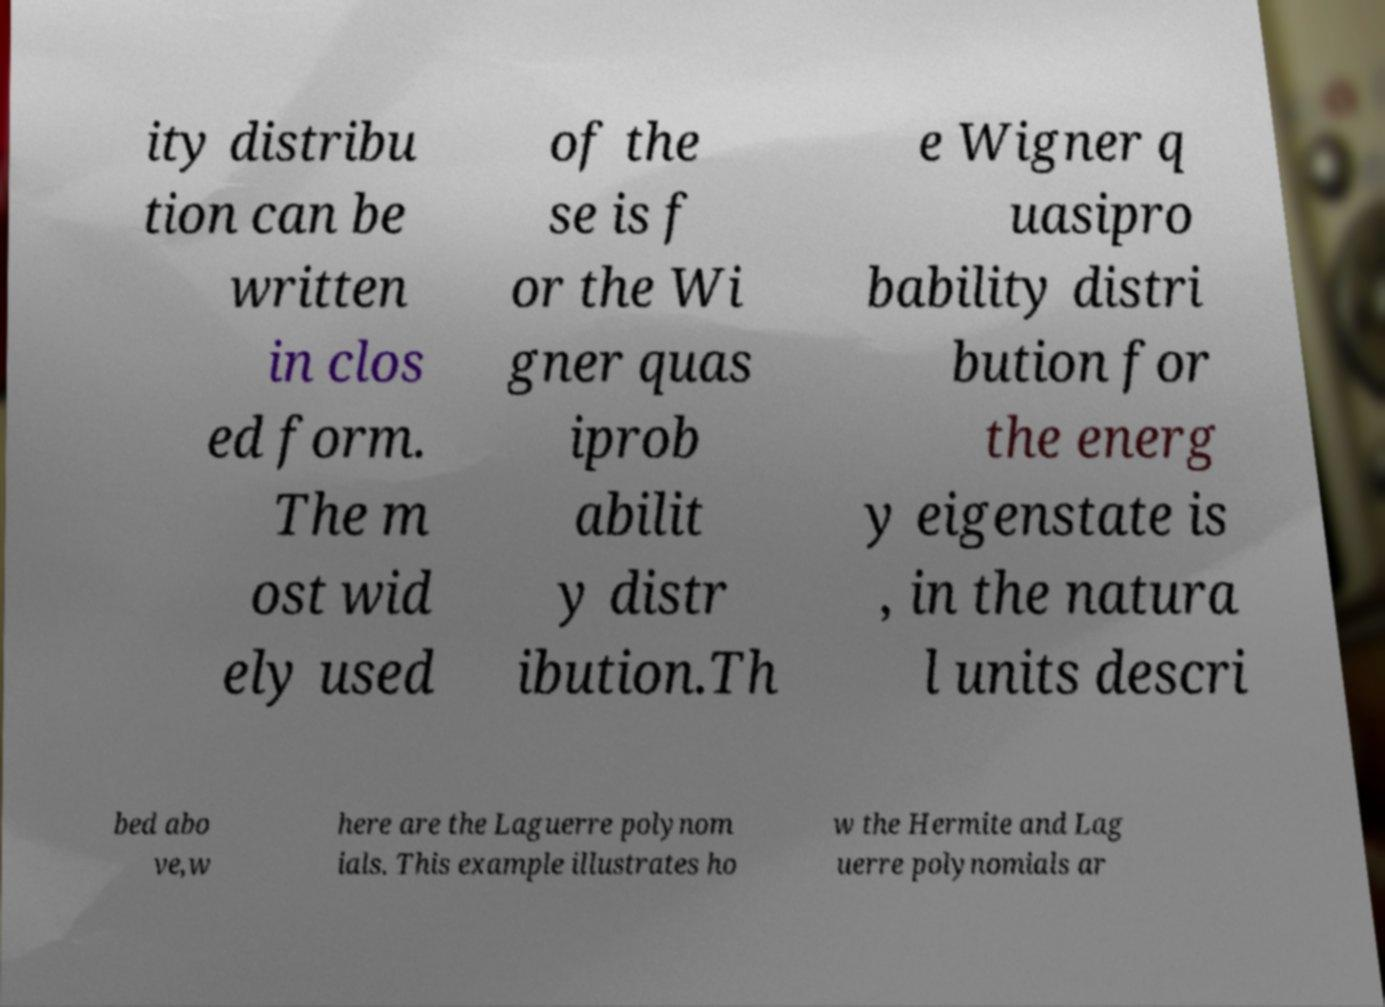I need the written content from this picture converted into text. Can you do that? ity distribu tion can be written in clos ed form. The m ost wid ely used of the se is f or the Wi gner quas iprob abilit y distr ibution.Th e Wigner q uasipro bability distri bution for the energ y eigenstate is , in the natura l units descri bed abo ve,w here are the Laguerre polynom ials. This example illustrates ho w the Hermite and Lag uerre polynomials ar 